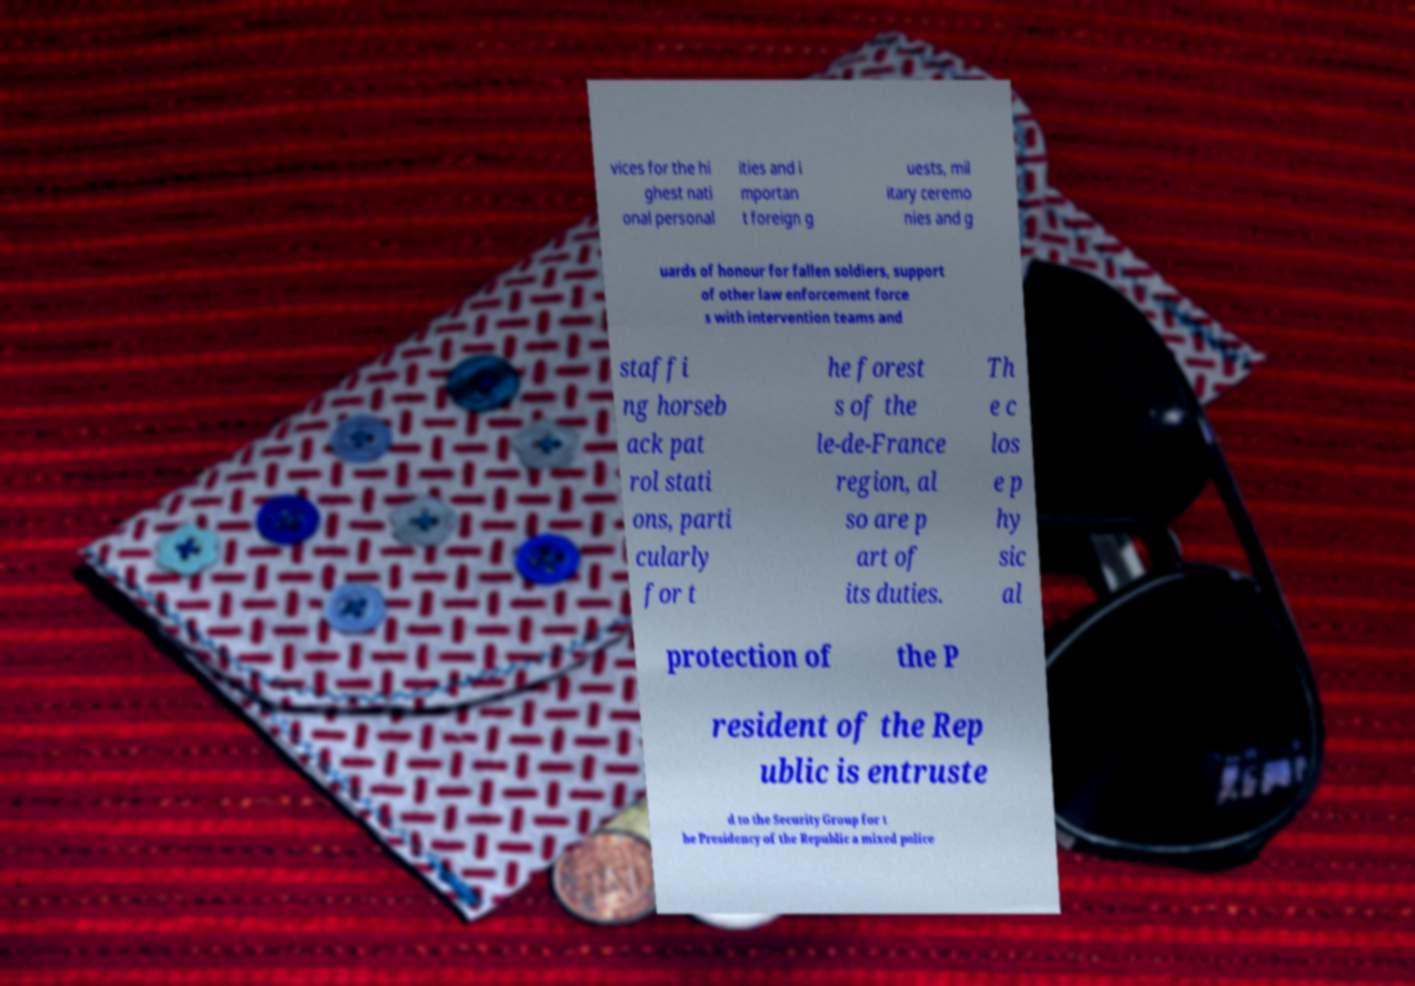There's text embedded in this image that I need extracted. Can you transcribe it verbatim? vices for the hi ghest nati onal personal ities and i mportan t foreign g uests, mil itary ceremo nies and g uards of honour for fallen soldiers, support of other law enforcement force s with intervention teams and staffi ng horseb ack pat rol stati ons, parti cularly for t he forest s of the le-de-France region, al so are p art of its duties. Th e c los e p hy sic al protection of the P resident of the Rep ublic is entruste d to the Security Group for t he Presidency of the Republic a mixed police 